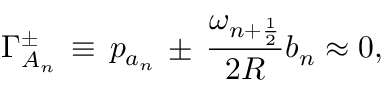Convert formula to latex. <formula><loc_0><loc_0><loc_500><loc_500>\Gamma _ { A _ { n } } ^ { \pm } \, \equiv \, p _ { a _ { n } } \, \pm \, \frac { \omega _ { n + \frac { 1 } { 2 } } } { 2 R } b _ { n } \approx 0 ,</formula> 